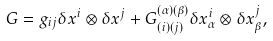<formula> <loc_0><loc_0><loc_500><loc_500>G = g _ { i j } \delta x ^ { i } \otimes \delta x ^ { j } + G ^ { ( \alpha ) ( \beta ) } _ { ( i ) ( j ) } \delta x ^ { i } _ { \alpha } \otimes \delta x ^ { j } _ { \beta } ,</formula> 